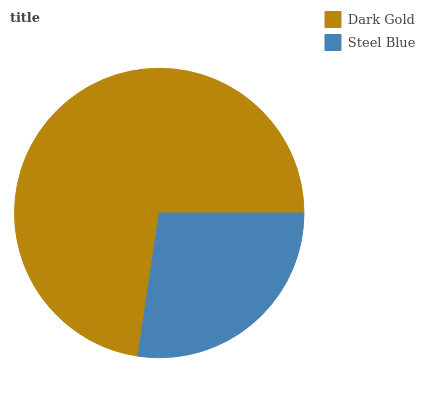Is Steel Blue the minimum?
Answer yes or no. Yes. Is Dark Gold the maximum?
Answer yes or no. Yes. Is Steel Blue the maximum?
Answer yes or no. No. Is Dark Gold greater than Steel Blue?
Answer yes or no. Yes. Is Steel Blue less than Dark Gold?
Answer yes or no. Yes. Is Steel Blue greater than Dark Gold?
Answer yes or no. No. Is Dark Gold less than Steel Blue?
Answer yes or no. No. Is Dark Gold the high median?
Answer yes or no. Yes. Is Steel Blue the low median?
Answer yes or no. Yes. Is Steel Blue the high median?
Answer yes or no. No. Is Dark Gold the low median?
Answer yes or no. No. 